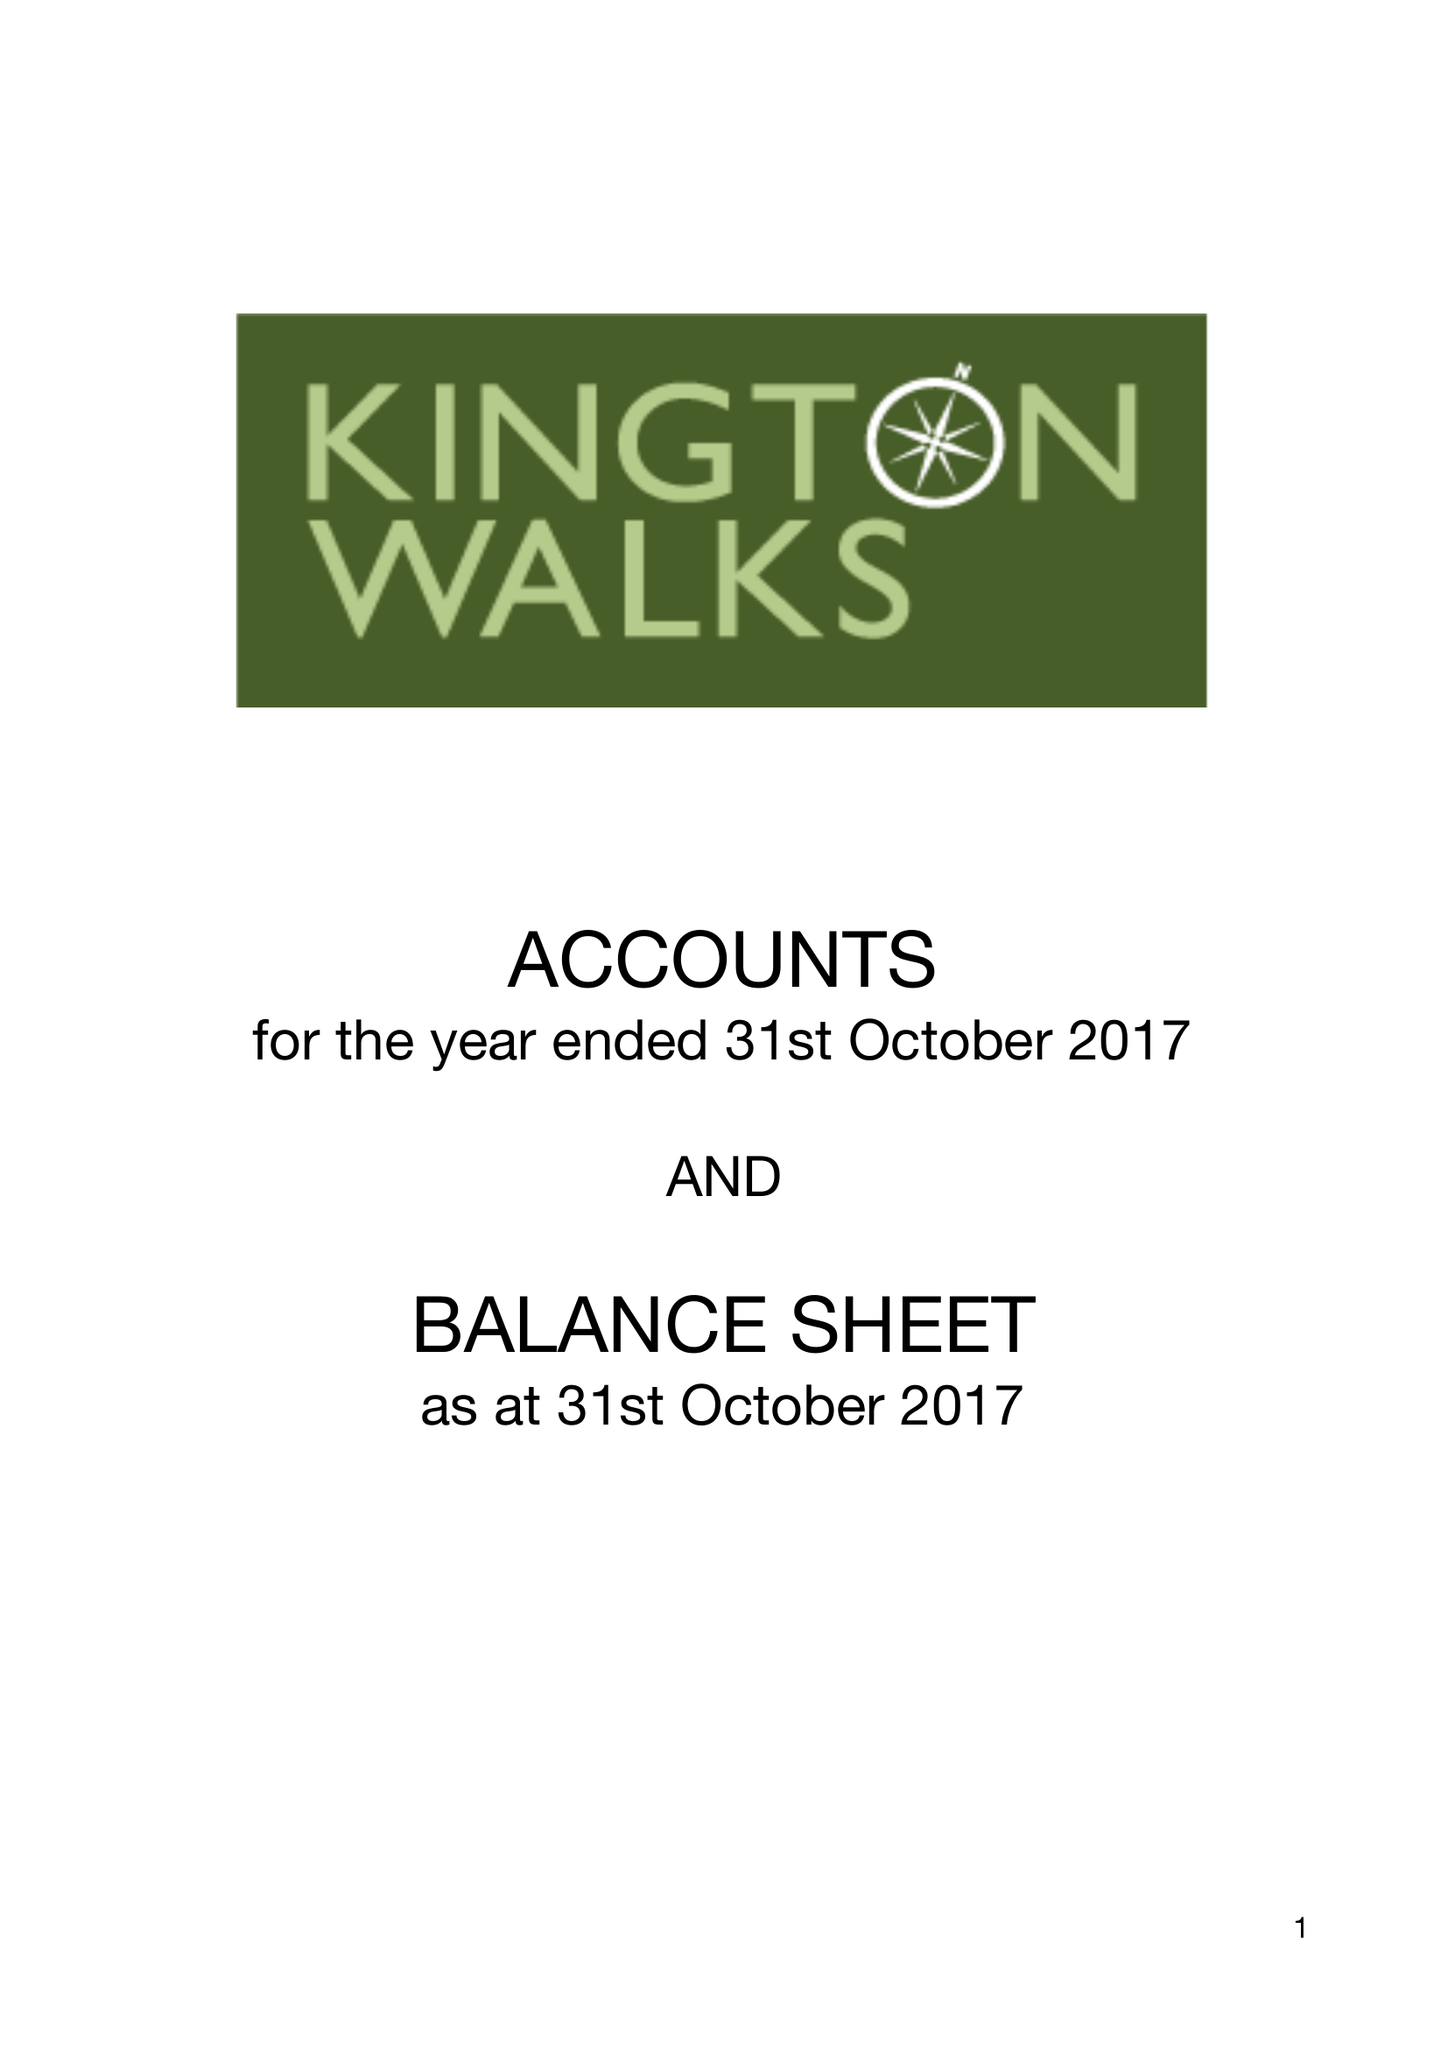What is the value for the charity_name?
Answer the question using a single word or phrase. Kington Walks 